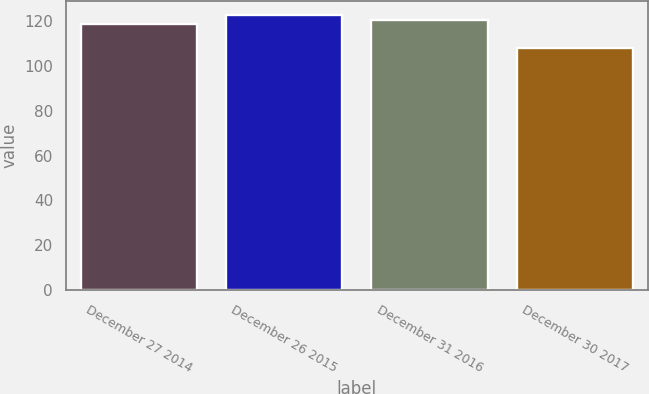Convert chart to OTSL. <chart><loc_0><loc_0><loc_500><loc_500><bar_chart><fcel>December 27 2014<fcel>December 26 2015<fcel>December 31 2016<fcel>December 30 2017<nl><fcel>119<fcel>123<fcel>120.5<fcel>108<nl></chart> 